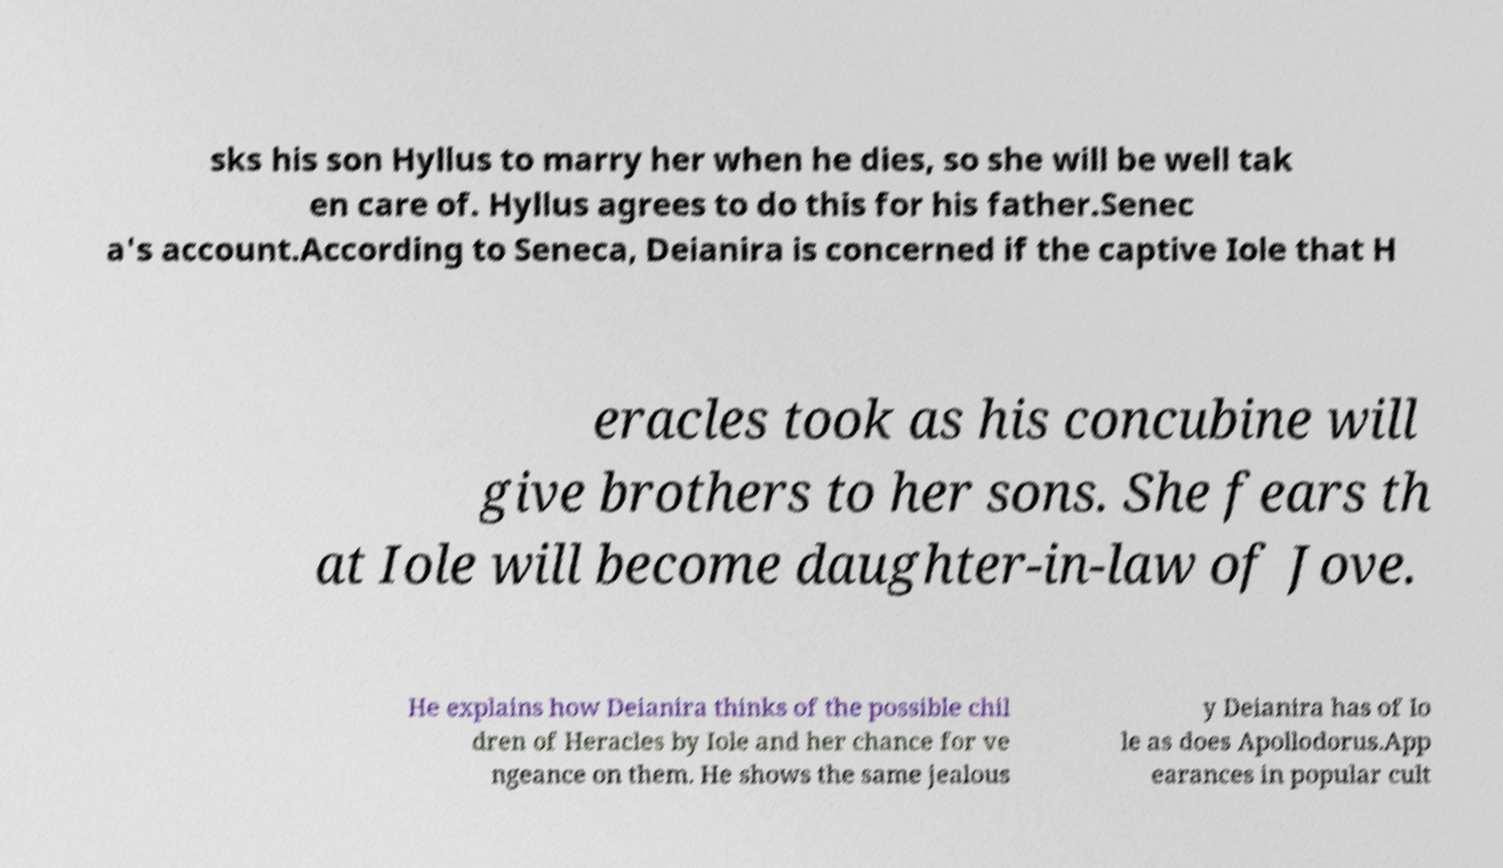Could you extract and type out the text from this image? sks his son Hyllus to marry her when he dies, so she will be well tak en care of. Hyllus agrees to do this for his father.Senec a's account.According to Seneca, Deianira is concerned if the captive Iole that H eracles took as his concubine will give brothers to her sons. She fears th at Iole will become daughter-in-law of Jove. He explains how Deianira thinks of the possible chil dren of Heracles by Iole and her chance for ve ngeance on them. He shows the same jealous y Deianira has of Io le as does Apollodorus.App earances in popular cult 